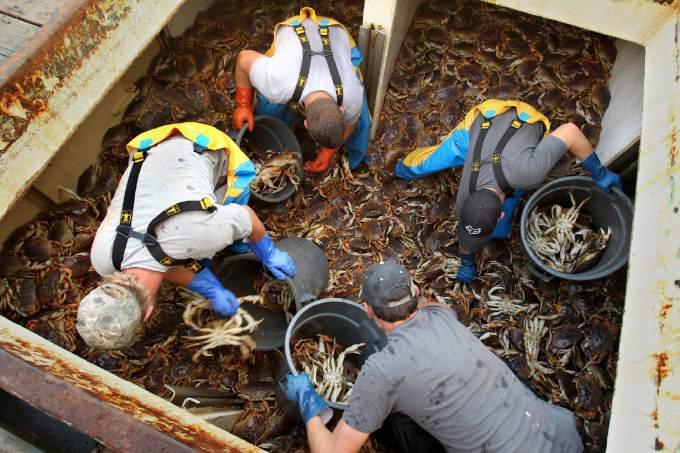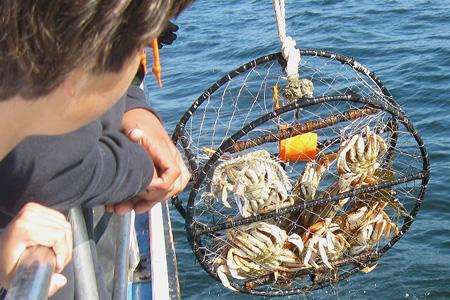The first image is the image on the left, the second image is the image on the right. Examine the images to the left and right. Is the description "Left and right images each show crab claws in some type of container used in a kitchen." accurate? Answer yes or no. No. The first image is the image on the left, the second image is the image on the right. Analyze the images presented: Is the assertion "One of the images has cooked crab pieces on foil." valid? Answer yes or no. No. 